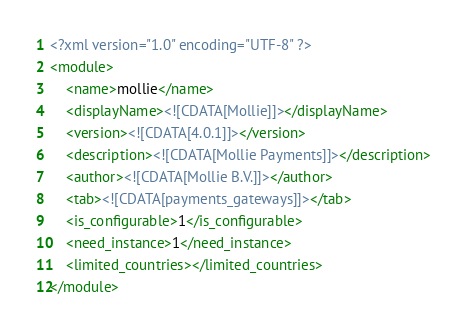<code> <loc_0><loc_0><loc_500><loc_500><_XML_><?xml version="1.0" encoding="UTF-8" ?>
<module>
    <name>mollie</name>
    <displayName><![CDATA[Mollie]]></displayName>
    <version><![CDATA[4.0.1]]></version>
    <description><![CDATA[Mollie Payments]]></description>
    <author><![CDATA[Mollie B.V.]]></author>
    <tab><![CDATA[payments_gateways]]></tab>
    <is_configurable>1</is_configurable>
    <need_instance>1</need_instance>
	<limited_countries></limited_countries>
</module></code> 